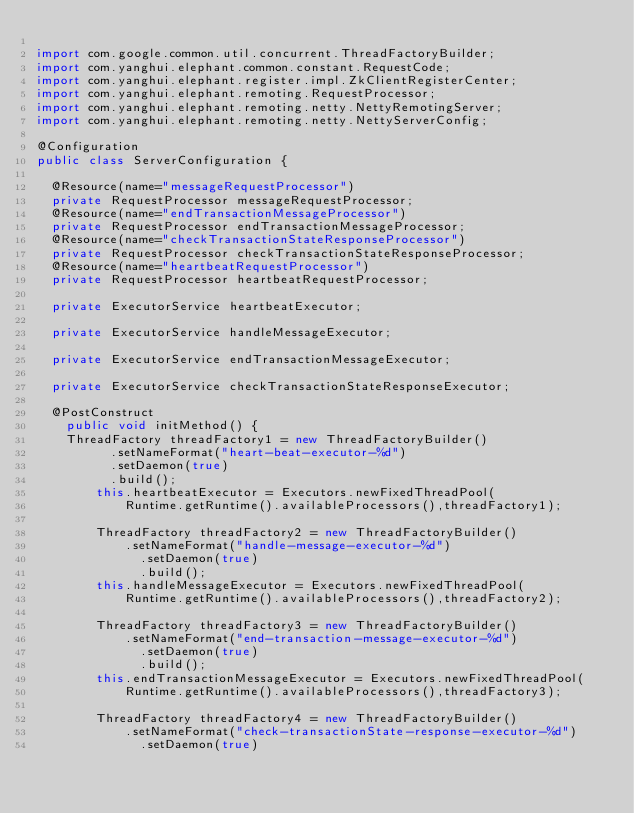<code> <loc_0><loc_0><loc_500><loc_500><_Java_>
import com.google.common.util.concurrent.ThreadFactoryBuilder;
import com.yanghui.elephant.common.constant.RequestCode;
import com.yanghui.elephant.register.impl.ZkClientRegisterCenter;
import com.yanghui.elephant.remoting.RequestProcessor;
import com.yanghui.elephant.remoting.netty.NettyRemotingServer;
import com.yanghui.elephant.remoting.netty.NettyServerConfig;

@Configuration
public class ServerConfiguration {
	
	@Resource(name="messageRequestProcessor")
	private RequestProcessor messageRequestProcessor;
	@Resource(name="endTransactionMessageProcessor")
	private RequestProcessor endTransactionMessageProcessor;
	@Resource(name="checkTransactionStateResponseProcessor")
	private RequestProcessor checkTransactionStateResponseProcessor;
	@Resource(name="heartbeatRequestProcessor")
	private RequestProcessor heartbeatRequestProcessor;
	
	private ExecutorService heartbeatExecutor;
	
	private ExecutorService handleMessageExecutor;
	
	private ExecutorService endTransactionMessageExecutor;
	
	private ExecutorService checkTransactionStateResponseExecutor;
	
	@PostConstruct
    public void initMethod() {
		ThreadFactory threadFactory1 = new ThreadFactoryBuilder()
	        .setNameFormat("heart-beat-executor-%d")
	        .setDaemon(true)
	        .build();
        this.heartbeatExecutor = Executors.newFixedThreadPool(
        		Runtime.getRuntime().availableProcessors(),threadFactory1);
    
        ThreadFactory threadFactory2 = new ThreadFactoryBuilder()
        		.setNameFormat("handle-message-executor-%d")
    	        .setDaemon(true)
    	        .build();
        this.handleMessageExecutor = Executors.newFixedThreadPool(
        		Runtime.getRuntime().availableProcessors(),threadFactory2);
        
        ThreadFactory threadFactory3 = new ThreadFactoryBuilder()
        		.setNameFormat("end-transaction-message-executor-%d")
    	        .setDaemon(true)
    	        .build();
        this.endTransactionMessageExecutor = Executors.newFixedThreadPool(
        		Runtime.getRuntime().availableProcessors(),threadFactory3);
        
        ThreadFactory threadFactory4 = new ThreadFactoryBuilder()
        		.setNameFormat("check-transactionState-response-executor-%d")
    	        .setDaemon(true)</code> 